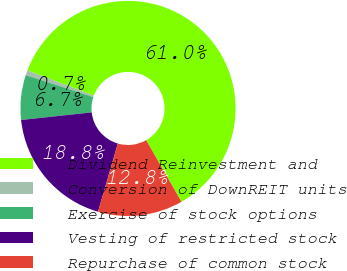Convert chart to OTSL. <chart><loc_0><loc_0><loc_500><loc_500><pie_chart><fcel>Dividend Reinvestment and<fcel>Conversion of DownREIT units<fcel>Exercise of stock options<fcel>Vesting of restricted stock<fcel>Repurchase of common stock<nl><fcel>60.98%<fcel>0.72%<fcel>6.74%<fcel>18.79%<fcel>12.77%<nl></chart> 